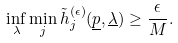Convert formula to latex. <formula><loc_0><loc_0><loc_500><loc_500>\inf _ { \lambda } \min _ { j } \tilde { h } ^ { ( \epsilon ) } _ { j } ( \underline { p } , \underline { \lambda } ) \geq \frac { \epsilon } { M } .</formula> 